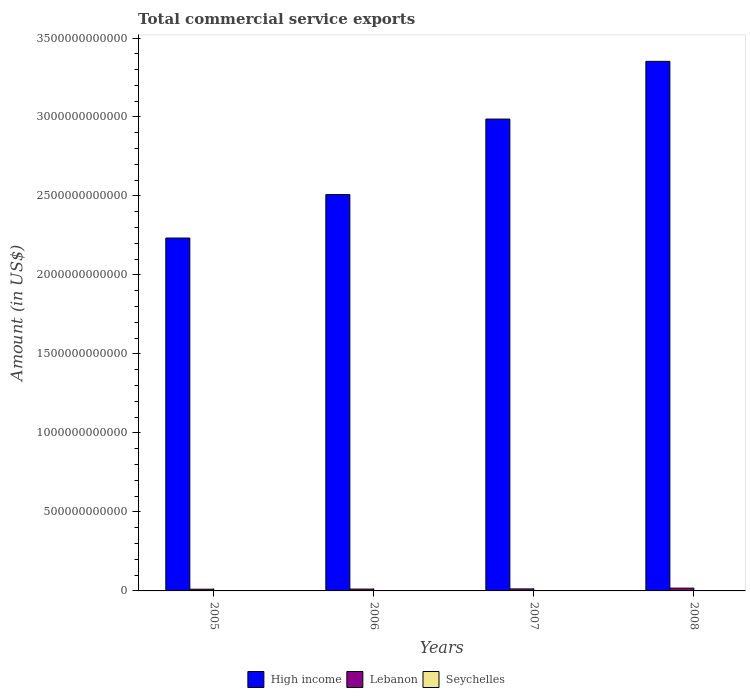How many groups of bars are there?
Offer a terse response. 4. Are the number of bars on each tick of the X-axis equal?
Ensure brevity in your answer.  Yes. How many bars are there on the 3rd tick from the left?
Offer a terse response. 3. In how many cases, is the number of bars for a given year not equal to the number of legend labels?
Your answer should be very brief. 0. What is the total commercial service exports in Lebanon in 2008?
Your response must be concise. 1.76e+1. Across all years, what is the maximum total commercial service exports in Seychelles?
Provide a succinct answer. 4.64e+08. Across all years, what is the minimum total commercial service exports in High income?
Keep it short and to the point. 2.23e+12. What is the total total commercial service exports in High income in the graph?
Your answer should be very brief. 1.11e+13. What is the difference between the total commercial service exports in Seychelles in 2005 and that in 2006?
Offer a terse response. -6.17e+07. What is the difference between the total commercial service exports in Lebanon in 2007 and the total commercial service exports in Seychelles in 2005?
Ensure brevity in your answer.  1.24e+1. What is the average total commercial service exports in Lebanon per year?
Offer a very short reply. 1.32e+1. In the year 2006, what is the difference between the total commercial service exports in High income and total commercial service exports in Seychelles?
Your answer should be very brief. 2.51e+12. What is the ratio of the total commercial service exports in High income in 2006 to that in 2007?
Your answer should be very brief. 0.84. Is the difference between the total commercial service exports in High income in 2007 and 2008 greater than the difference between the total commercial service exports in Seychelles in 2007 and 2008?
Offer a terse response. No. What is the difference between the highest and the second highest total commercial service exports in Lebanon?
Make the answer very short. 4.87e+09. What is the difference between the highest and the lowest total commercial service exports in High income?
Offer a terse response. 1.12e+12. In how many years, is the total commercial service exports in Seychelles greater than the average total commercial service exports in Seychelles taken over all years?
Your response must be concise. 2. Is the sum of the total commercial service exports in Seychelles in 2005 and 2006 greater than the maximum total commercial service exports in Lebanon across all years?
Offer a terse response. No. What does the 2nd bar from the left in 2007 represents?
Provide a succinct answer. Lebanon. What does the 2nd bar from the right in 2006 represents?
Ensure brevity in your answer.  Lebanon. Are all the bars in the graph horizontal?
Your answer should be compact. No. What is the difference between two consecutive major ticks on the Y-axis?
Your answer should be very brief. 5.00e+11. Does the graph contain grids?
Your response must be concise. No. What is the title of the graph?
Ensure brevity in your answer.  Total commercial service exports. Does "Northern Mariana Islands" appear as one of the legend labels in the graph?
Offer a very short reply. No. What is the label or title of the X-axis?
Give a very brief answer. Years. What is the label or title of the Y-axis?
Keep it short and to the point. Amount (in US$). What is the Amount (in US$) of High income in 2005?
Keep it short and to the point. 2.23e+12. What is the Amount (in US$) of Lebanon in 2005?
Ensure brevity in your answer.  1.08e+1. What is the Amount (in US$) in Seychelles in 2005?
Make the answer very short. 3.48e+08. What is the Amount (in US$) of High income in 2006?
Make the answer very short. 2.51e+12. What is the Amount (in US$) of Lebanon in 2006?
Your answer should be very brief. 1.17e+1. What is the Amount (in US$) in Seychelles in 2006?
Keep it short and to the point. 4.10e+08. What is the Amount (in US$) of High income in 2007?
Your answer should be very brief. 2.99e+12. What is the Amount (in US$) of Lebanon in 2007?
Offer a terse response. 1.27e+1. What is the Amount (in US$) of Seychelles in 2007?
Make the answer very short. 4.56e+08. What is the Amount (in US$) in High income in 2008?
Your answer should be very brief. 3.35e+12. What is the Amount (in US$) in Lebanon in 2008?
Your response must be concise. 1.76e+1. What is the Amount (in US$) in Seychelles in 2008?
Offer a very short reply. 4.64e+08. Across all years, what is the maximum Amount (in US$) of High income?
Your answer should be very brief. 3.35e+12. Across all years, what is the maximum Amount (in US$) in Lebanon?
Make the answer very short. 1.76e+1. Across all years, what is the maximum Amount (in US$) in Seychelles?
Offer a terse response. 4.64e+08. Across all years, what is the minimum Amount (in US$) in High income?
Ensure brevity in your answer.  2.23e+12. Across all years, what is the minimum Amount (in US$) of Lebanon?
Offer a very short reply. 1.08e+1. Across all years, what is the minimum Amount (in US$) of Seychelles?
Ensure brevity in your answer.  3.48e+08. What is the total Amount (in US$) of High income in the graph?
Give a very brief answer. 1.11e+13. What is the total Amount (in US$) in Lebanon in the graph?
Provide a succinct answer. 5.29e+1. What is the total Amount (in US$) of Seychelles in the graph?
Your answer should be very brief. 1.68e+09. What is the difference between the Amount (in US$) in High income in 2005 and that in 2006?
Keep it short and to the point. -2.75e+11. What is the difference between the Amount (in US$) in Lebanon in 2005 and that in 2006?
Your answer should be compact. -8.12e+08. What is the difference between the Amount (in US$) of Seychelles in 2005 and that in 2006?
Offer a very short reply. -6.17e+07. What is the difference between the Amount (in US$) in High income in 2005 and that in 2007?
Your answer should be very brief. -7.53e+11. What is the difference between the Amount (in US$) in Lebanon in 2005 and that in 2007?
Make the answer very short. -1.90e+09. What is the difference between the Amount (in US$) in Seychelles in 2005 and that in 2007?
Ensure brevity in your answer.  -1.08e+08. What is the difference between the Amount (in US$) in High income in 2005 and that in 2008?
Give a very brief answer. -1.12e+12. What is the difference between the Amount (in US$) in Lebanon in 2005 and that in 2008?
Provide a succinct answer. -6.77e+09. What is the difference between the Amount (in US$) of Seychelles in 2005 and that in 2008?
Give a very brief answer. -1.16e+08. What is the difference between the Amount (in US$) of High income in 2006 and that in 2007?
Make the answer very short. -4.78e+11. What is the difference between the Amount (in US$) of Lebanon in 2006 and that in 2007?
Offer a terse response. -1.09e+09. What is the difference between the Amount (in US$) of Seychelles in 2006 and that in 2007?
Give a very brief answer. -4.65e+07. What is the difference between the Amount (in US$) of High income in 2006 and that in 2008?
Provide a short and direct response. -8.44e+11. What is the difference between the Amount (in US$) in Lebanon in 2006 and that in 2008?
Your answer should be compact. -5.96e+09. What is the difference between the Amount (in US$) of Seychelles in 2006 and that in 2008?
Offer a very short reply. -5.48e+07. What is the difference between the Amount (in US$) in High income in 2007 and that in 2008?
Make the answer very short. -3.65e+11. What is the difference between the Amount (in US$) of Lebanon in 2007 and that in 2008?
Your answer should be very brief. -4.87e+09. What is the difference between the Amount (in US$) in Seychelles in 2007 and that in 2008?
Offer a terse response. -8.28e+06. What is the difference between the Amount (in US$) in High income in 2005 and the Amount (in US$) in Lebanon in 2006?
Your response must be concise. 2.22e+12. What is the difference between the Amount (in US$) in High income in 2005 and the Amount (in US$) in Seychelles in 2006?
Provide a succinct answer. 2.23e+12. What is the difference between the Amount (in US$) in Lebanon in 2005 and the Amount (in US$) in Seychelles in 2006?
Offer a very short reply. 1.04e+1. What is the difference between the Amount (in US$) in High income in 2005 and the Amount (in US$) in Lebanon in 2007?
Give a very brief answer. 2.22e+12. What is the difference between the Amount (in US$) of High income in 2005 and the Amount (in US$) of Seychelles in 2007?
Ensure brevity in your answer.  2.23e+12. What is the difference between the Amount (in US$) in Lebanon in 2005 and the Amount (in US$) in Seychelles in 2007?
Make the answer very short. 1.04e+1. What is the difference between the Amount (in US$) of High income in 2005 and the Amount (in US$) of Lebanon in 2008?
Your answer should be very brief. 2.22e+12. What is the difference between the Amount (in US$) in High income in 2005 and the Amount (in US$) in Seychelles in 2008?
Your response must be concise. 2.23e+12. What is the difference between the Amount (in US$) in Lebanon in 2005 and the Amount (in US$) in Seychelles in 2008?
Your answer should be very brief. 1.04e+1. What is the difference between the Amount (in US$) in High income in 2006 and the Amount (in US$) in Lebanon in 2007?
Your answer should be very brief. 2.50e+12. What is the difference between the Amount (in US$) of High income in 2006 and the Amount (in US$) of Seychelles in 2007?
Offer a very short reply. 2.51e+12. What is the difference between the Amount (in US$) of Lebanon in 2006 and the Amount (in US$) of Seychelles in 2007?
Your answer should be very brief. 1.12e+1. What is the difference between the Amount (in US$) in High income in 2006 and the Amount (in US$) in Lebanon in 2008?
Provide a succinct answer. 2.49e+12. What is the difference between the Amount (in US$) of High income in 2006 and the Amount (in US$) of Seychelles in 2008?
Make the answer very short. 2.51e+12. What is the difference between the Amount (in US$) of Lebanon in 2006 and the Amount (in US$) of Seychelles in 2008?
Your answer should be compact. 1.12e+1. What is the difference between the Amount (in US$) in High income in 2007 and the Amount (in US$) in Lebanon in 2008?
Provide a succinct answer. 2.97e+12. What is the difference between the Amount (in US$) in High income in 2007 and the Amount (in US$) in Seychelles in 2008?
Provide a short and direct response. 2.99e+12. What is the difference between the Amount (in US$) of Lebanon in 2007 and the Amount (in US$) of Seychelles in 2008?
Keep it short and to the point. 1.23e+1. What is the average Amount (in US$) in High income per year?
Give a very brief answer. 2.77e+12. What is the average Amount (in US$) of Lebanon per year?
Give a very brief answer. 1.32e+1. What is the average Amount (in US$) of Seychelles per year?
Give a very brief answer. 4.19e+08. In the year 2005, what is the difference between the Amount (in US$) of High income and Amount (in US$) of Lebanon?
Provide a succinct answer. 2.22e+12. In the year 2005, what is the difference between the Amount (in US$) in High income and Amount (in US$) in Seychelles?
Ensure brevity in your answer.  2.23e+12. In the year 2005, what is the difference between the Amount (in US$) in Lebanon and Amount (in US$) in Seychelles?
Keep it short and to the point. 1.05e+1. In the year 2006, what is the difference between the Amount (in US$) of High income and Amount (in US$) of Lebanon?
Provide a short and direct response. 2.50e+12. In the year 2006, what is the difference between the Amount (in US$) in High income and Amount (in US$) in Seychelles?
Ensure brevity in your answer.  2.51e+12. In the year 2006, what is the difference between the Amount (in US$) of Lebanon and Amount (in US$) of Seychelles?
Give a very brief answer. 1.12e+1. In the year 2007, what is the difference between the Amount (in US$) in High income and Amount (in US$) in Lebanon?
Provide a succinct answer. 2.97e+12. In the year 2007, what is the difference between the Amount (in US$) in High income and Amount (in US$) in Seychelles?
Provide a short and direct response. 2.99e+12. In the year 2007, what is the difference between the Amount (in US$) in Lebanon and Amount (in US$) in Seychelles?
Your answer should be compact. 1.23e+1. In the year 2008, what is the difference between the Amount (in US$) in High income and Amount (in US$) in Lebanon?
Ensure brevity in your answer.  3.33e+12. In the year 2008, what is the difference between the Amount (in US$) of High income and Amount (in US$) of Seychelles?
Ensure brevity in your answer.  3.35e+12. In the year 2008, what is the difference between the Amount (in US$) in Lebanon and Amount (in US$) in Seychelles?
Provide a succinct answer. 1.72e+1. What is the ratio of the Amount (in US$) in High income in 2005 to that in 2006?
Your answer should be very brief. 0.89. What is the ratio of the Amount (in US$) in Lebanon in 2005 to that in 2006?
Provide a succinct answer. 0.93. What is the ratio of the Amount (in US$) of Seychelles in 2005 to that in 2006?
Make the answer very short. 0.85. What is the ratio of the Amount (in US$) of High income in 2005 to that in 2007?
Ensure brevity in your answer.  0.75. What is the ratio of the Amount (in US$) in Lebanon in 2005 to that in 2007?
Provide a short and direct response. 0.85. What is the ratio of the Amount (in US$) in Seychelles in 2005 to that in 2007?
Your answer should be compact. 0.76. What is the ratio of the Amount (in US$) of High income in 2005 to that in 2008?
Ensure brevity in your answer.  0.67. What is the ratio of the Amount (in US$) in Lebanon in 2005 to that in 2008?
Give a very brief answer. 0.62. What is the ratio of the Amount (in US$) of Seychelles in 2005 to that in 2008?
Offer a very short reply. 0.75. What is the ratio of the Amount (in US$) of High income in 2006 to that in 2007?
Your answer should be compact. 0.84. What is the ratio of the Amount (in US$) of Lebanon in 2006 to that in 2007?
Provide a short and direct response. 0.91. What is the ratio of the Amount (in US$) of Seychelles in 2006 to that in 2007?
Give a very brief answer. 0.9. What is the ratio of the Amount (in US$) of High income in 2006 to that in 2008?
Offer a terse response. 0.75. What is the ratio of the Amount (in US$) of Lebanon in 2006 to that in 2008?
Make the answer very short. 0.66. What is the ratio of the Amount (in US$) in Seychelles in 2006 to that in 2008?
Your answer should be very brief. 0.88. What is the ratio of the Amount (in US$) in High income in 2007 to that in 2008?
Keep it short and to the point. 0.89. What is the ratio of the Amount (in US$) in Lebanon in 2007 to that in 2008?
Ensure brevity in your answer.  0.72. What is the ratio of the Amount (in US$) in Seychelles in 2007 to that in 2008?
Offer a very short reply. 0.98. What is the difference between the highest and the second highest Amount (in US$) of High income?
Ensure brevity in your answer.  3.65e+11. What is the difference between the highest and the second highest Amount (in US$) in Lebanon?
Ensure brevity in your answer.  4.87e+09. What is the difference between the highest and the second highest Amount (in US$) in Seychelles?
Your answer should be very brief. 8.28e+06. What is the difference between the highest and the lowest Amount (in US$) in High income?
Give a very brief answer. 1.12e+12. What is the difference between the highest and the lowest Amount (in US$) in Lebanon?
Make the answer very short. 6.77e+09. What is the difference between the highest and the lowest Amount (in US$) of Seychelles?
Ensure brevity in your answer.  1.16e+08. 